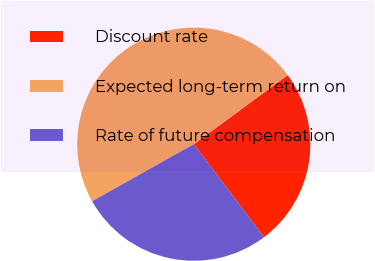Convert chart. <chart><loc_0><loc_0><loc_500><loc_500><pie_chart><fcel>Discount rate<fcel>Expected long-term return on<fcel>Rate of future compensation<nl><fcel>24.8%<fcel>48.05%<fcel>27.15%<nl></chart> 